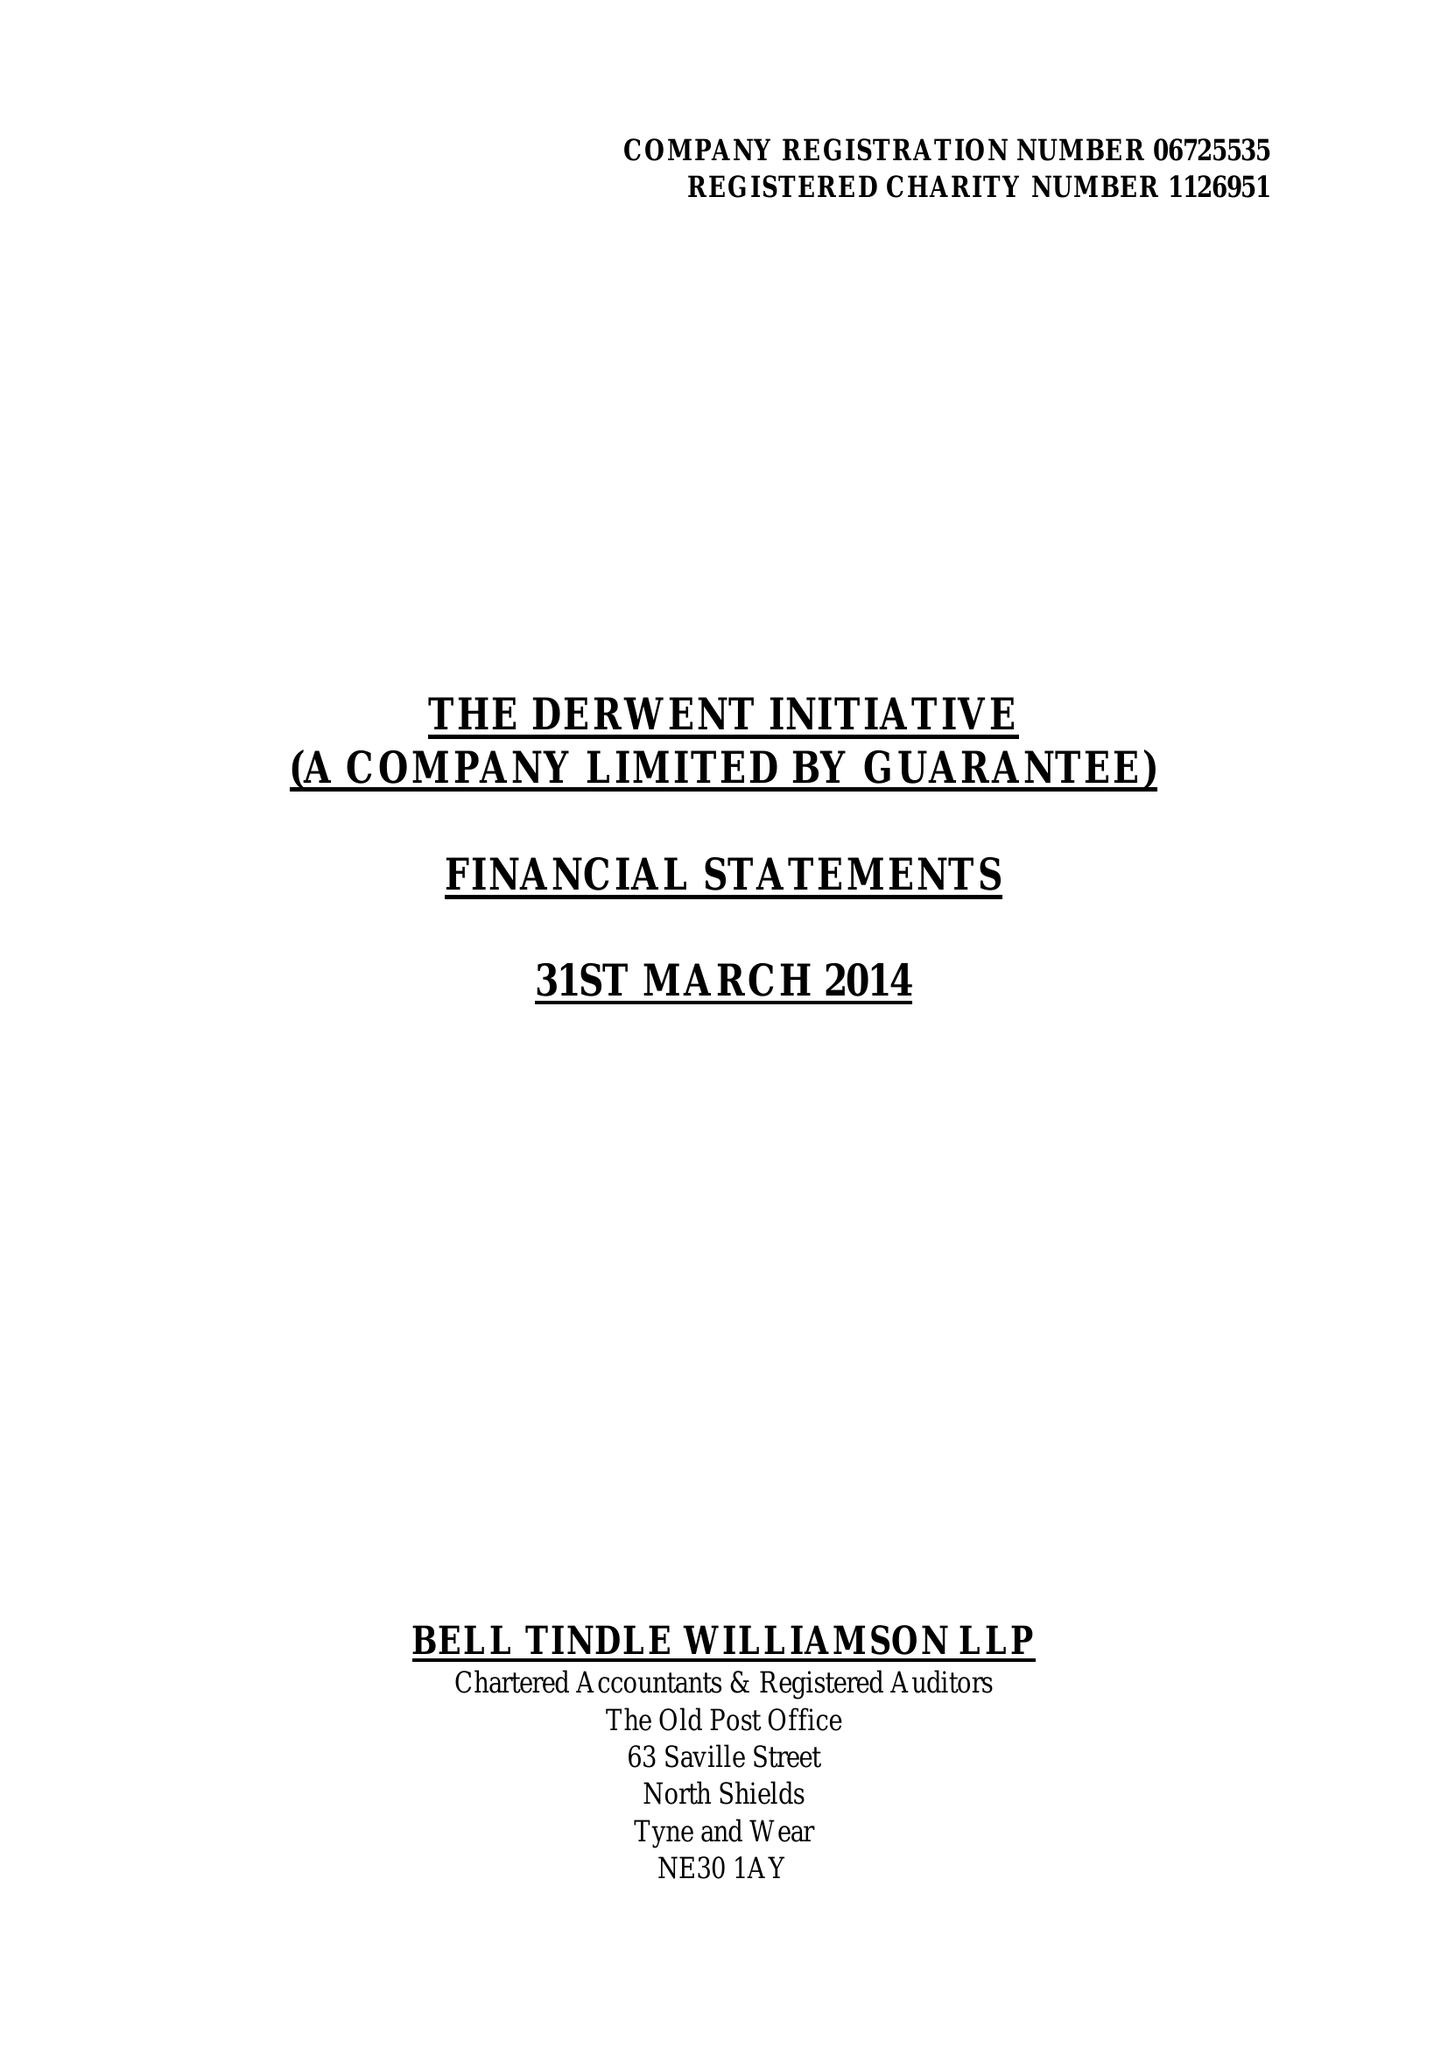What is the value for the spending_annually_in_british_pounds?
Answer the question using a single word or phrase. 185699.00 